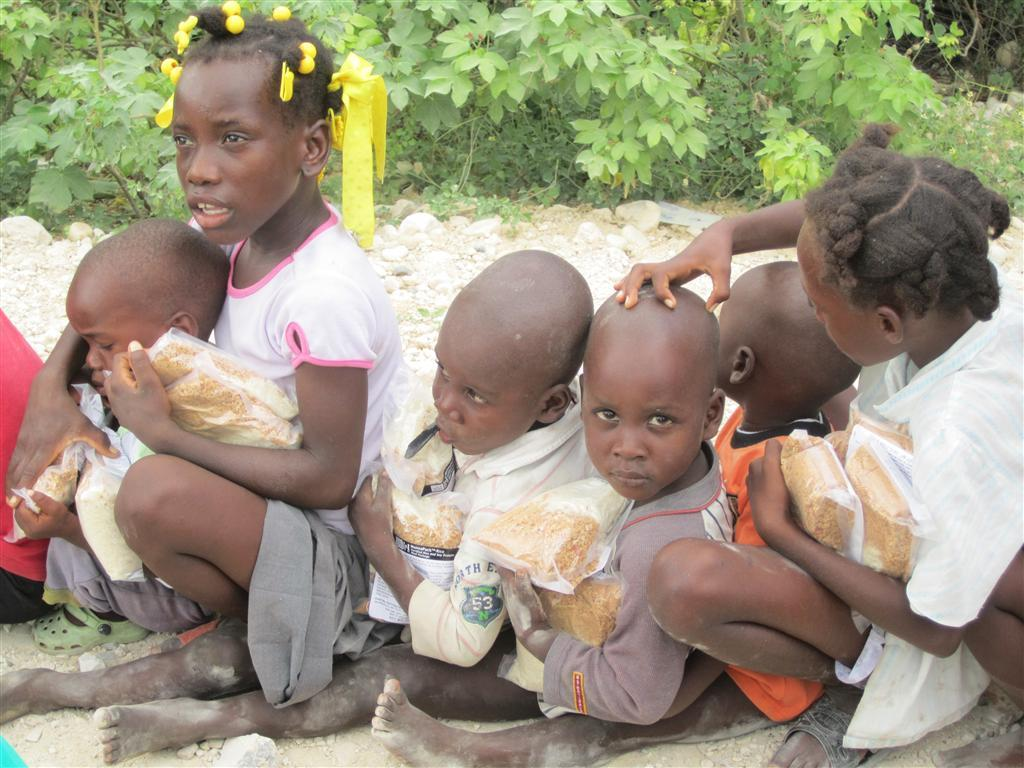Who is present in the image? There are children in the image. What are the children doing in the image? The children are sitting on the ground. What are the children holding in the image? The children are holding packets. What can be seen in the background of the image? There are plants in the background of the image. Can you tell me how many dinosaurs are present in the image? There are no dinosaurs present in the image; it features children sitting on the ground and holding packets. What type of bee can be seen buzzing around the children in the image? There is no bee present in the image; it only shows children sitting on the ground and holding packets. 